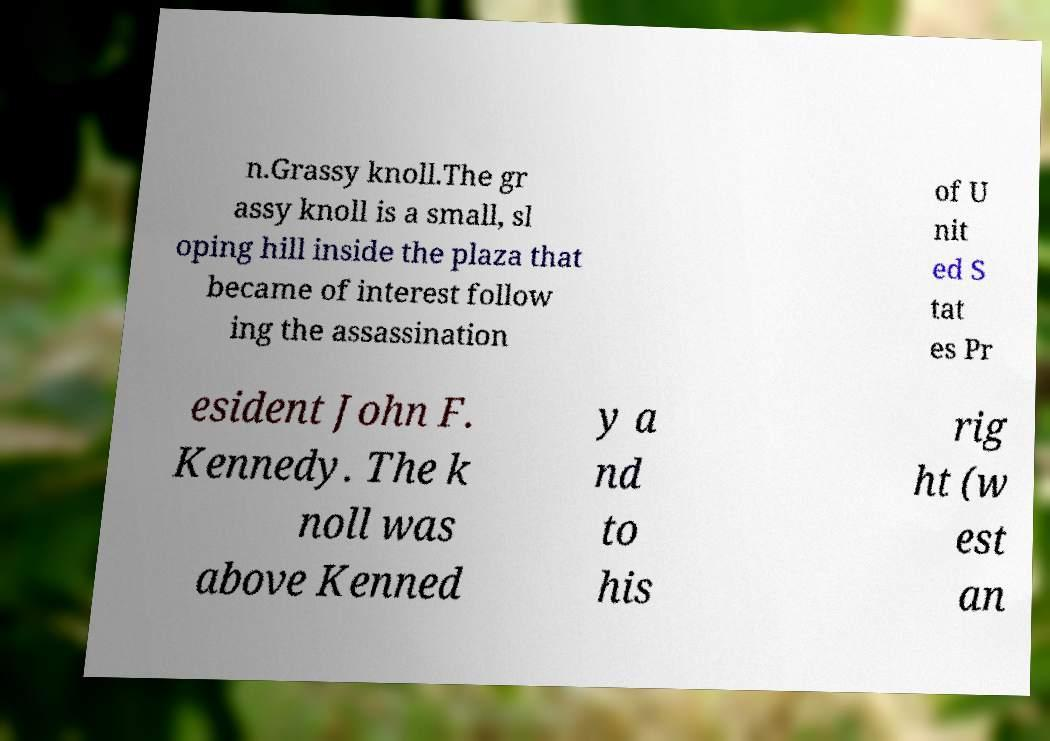Please identify and transcribe the text found in this image. n.Grassy knoll.The gr assy knoll is a small, sl oping hill inside the plaza that became of interest follow ing the assassination of U nit ed S tat es Pr esident John F. Kennedy. The k noll was above Kenned y a nd to his rig ht (w est an 